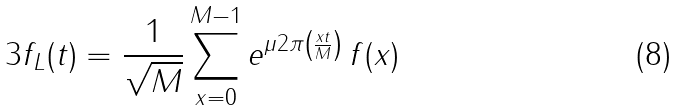<formula> <loc_0><loc_0><loc_500><loc_500>{ 3 } f _ { L } ( t ) = \frac { 1 } { \sqrt { M } } \sum _ { x = 0 } ^ { M - 1 } e ^ { \mu 2 \pi \left ( \frac { x t } { M } \right ) } \, f ( x )</formula> 